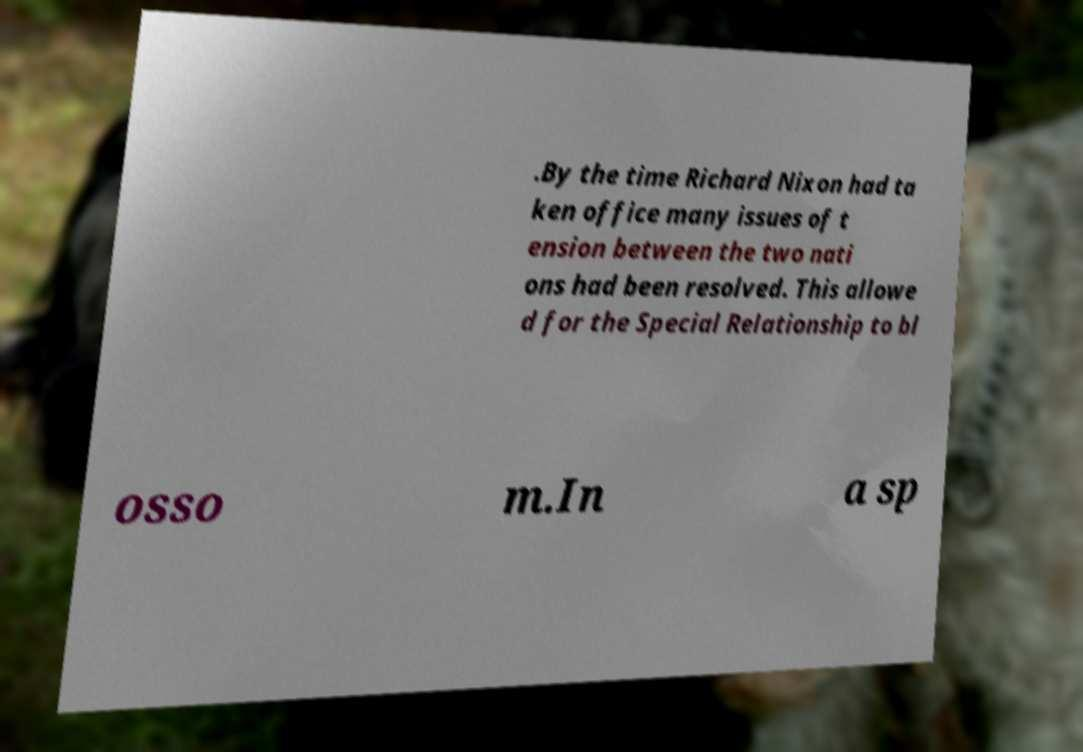Could you extract and type out the text from this image? .By the time Richard Nixon had ta ken office many issues of t ension between the two nati ons had been resolved. This allowe d for the Special Relationship to bl osso m.In a sp 